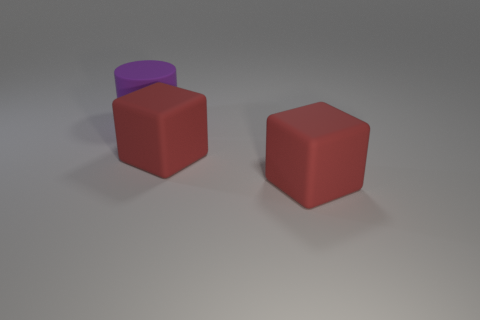Add 1 small gray shiny things. How many objects exist? 4 Subtract all cubes. How many objects are left? 1 Subtract 0 brown blocks. How many objects are left? 3 Subtract all red matte blocks. Subtract all purple objects. How many objects are left? 0 Add 2 large purple things. How many large purple things are left? 3 Add 3 large blue matte things. How many large blue matte things exist? 3 